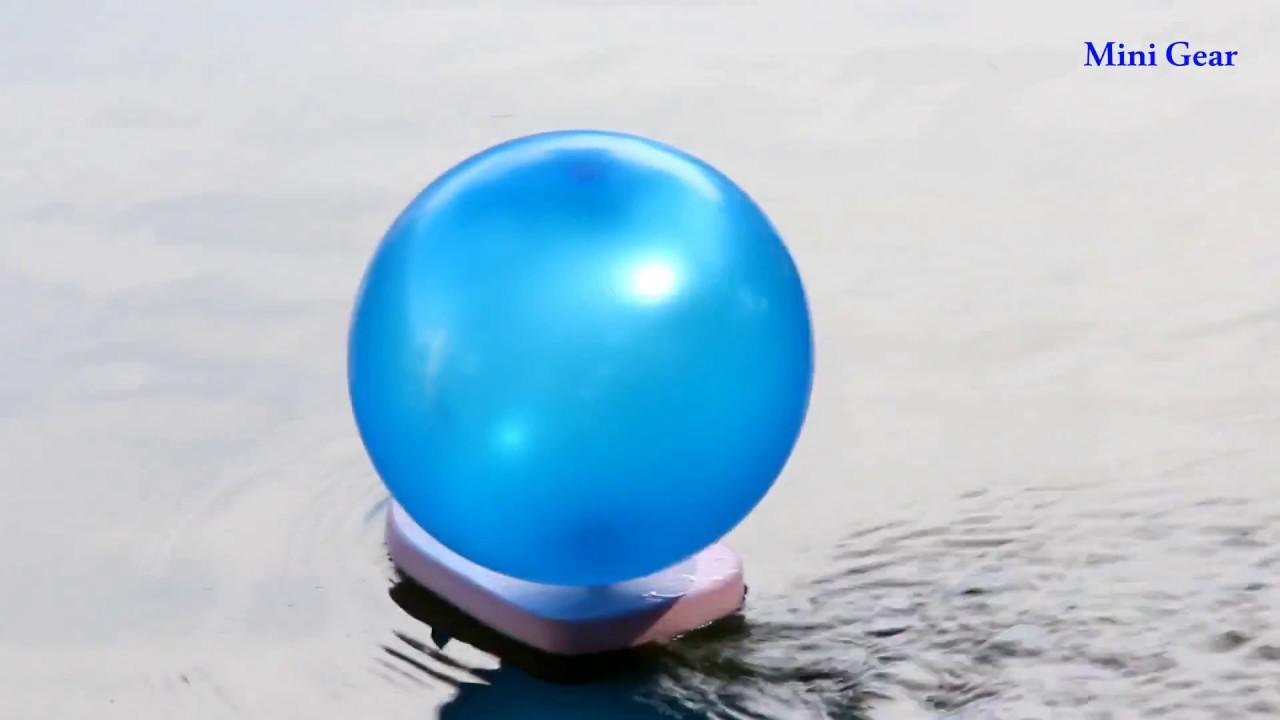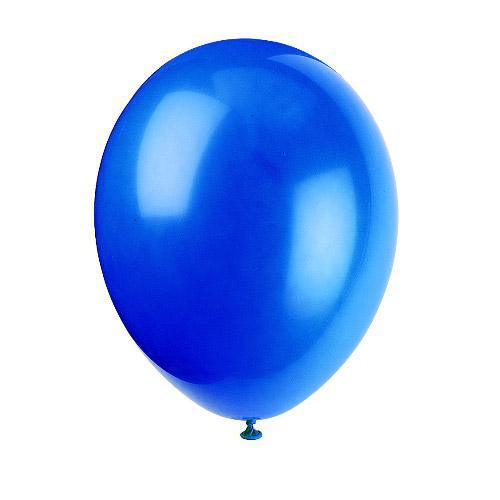The first image is the image on the left, the second image is the image on the right. Examine the images to the left and right. Is the description "the image on the right contains one round balloon on a white background" accurate? Answer yes or no. Yes. 